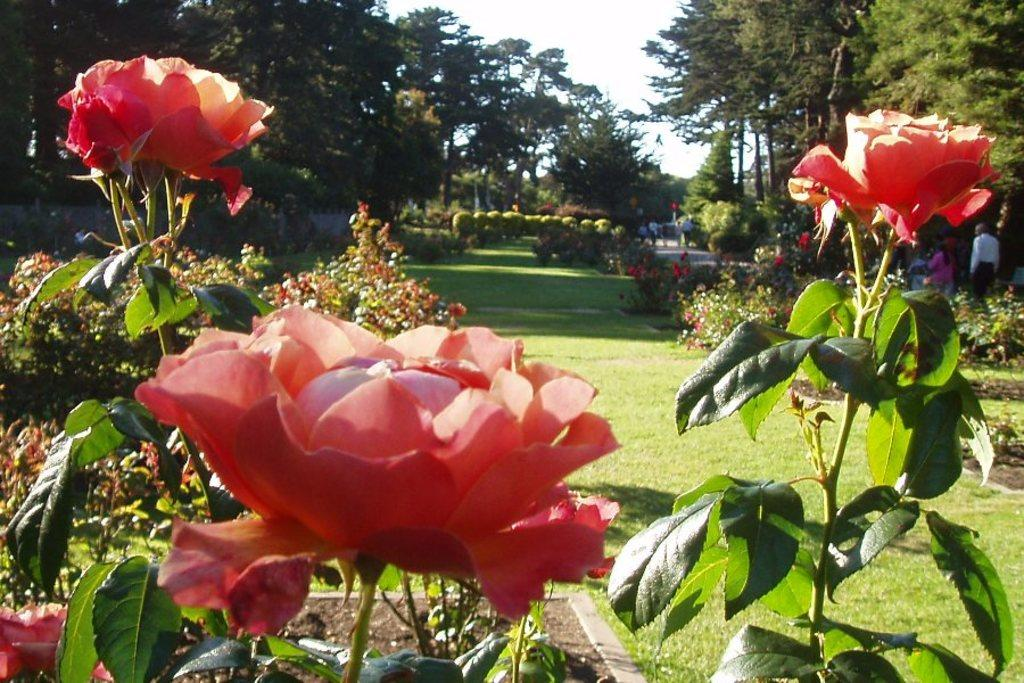What type of vegetation can be seen in the image? There are flowers, plants, trees, and grass visible in the image. What are the people in the image doing? The people in the image are walking on a path. What is visible in the background of the image? The sky is visible in the background of the image. Where is the leather store located in the image? There is no leather store present in the image. What verse can be seen written on the trees in the image? There are no verses written on the trees in the image; only vegetation and people walking on a path are present. 